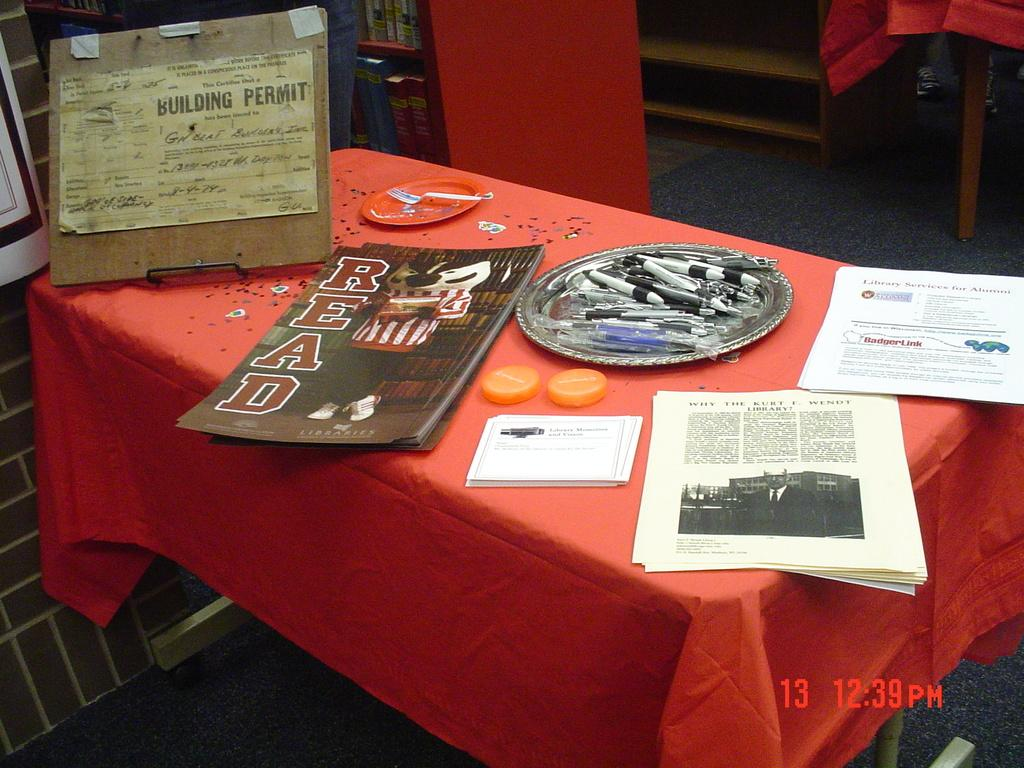<image>
Give a short and clear explanation of the subsequent image. A table has a red table cloth and posters that say Read on it. 